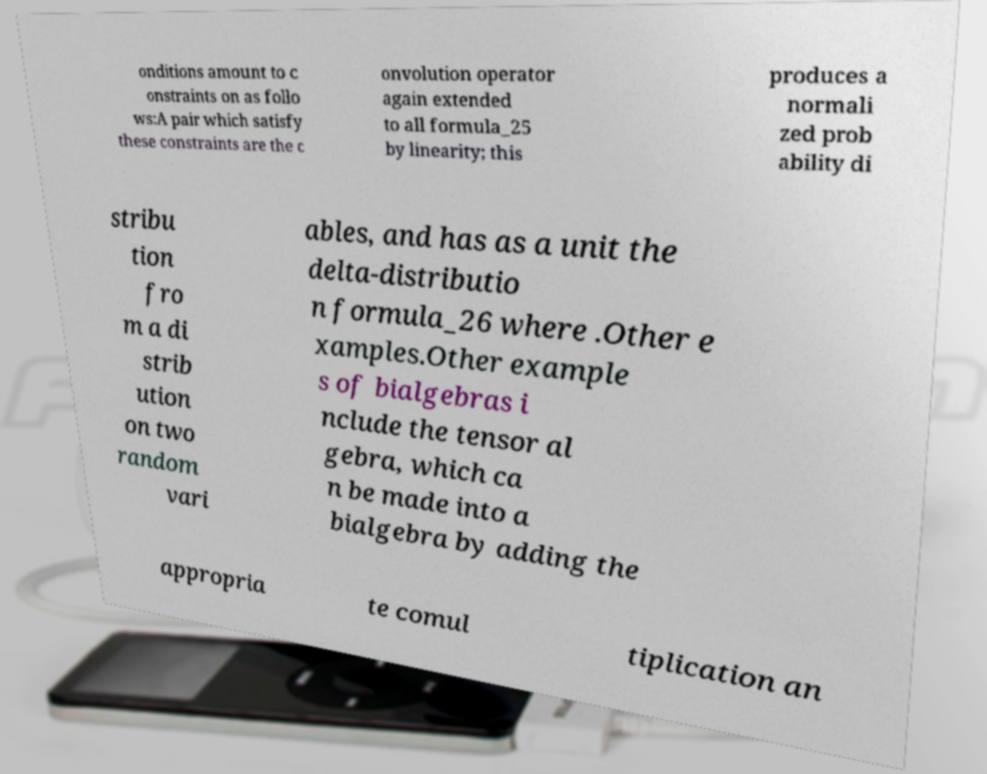Please read and relay the text visible in this image. What does it say? onditions amount to c onstraints on as follo ws:A pair which satisfy these constraints are the c onvolution operator again extended to all formula_25 by linearity; this produces a normali zed prob ability di stribu tion fro m a di strib ution on two random vari ables, and has as a unit the delta-distributio n formula_26 where .Other e xamples.Other example s of bialgebras i nclude the tensor al gebra, which ca n be made into a bialgebra by adding the appropria te comul tiplication an 